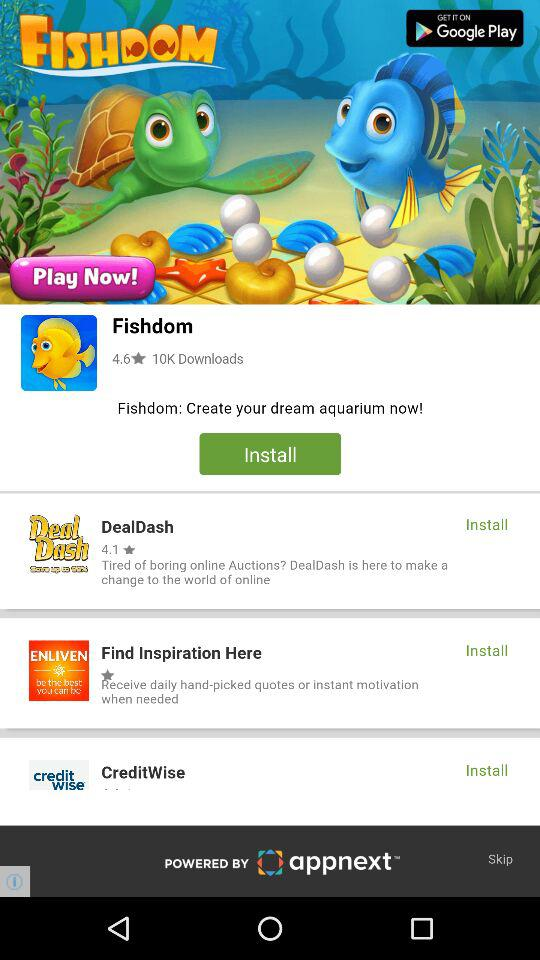Who is the developer of the application?
When the provided information is insufficient, respond with <no answer>. <no answer> 